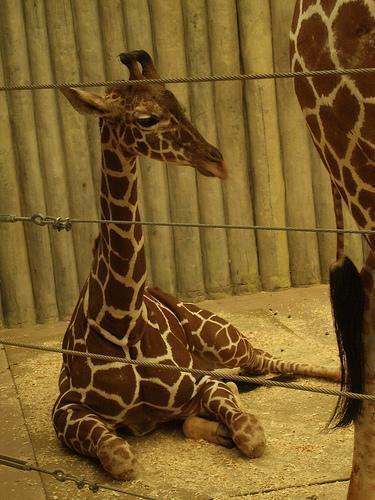How many ears are visible?
Give a very brief answer. 1. How many animals in the picture?
Give a very brief answer. 2. How many legs are shown?
Give a very brief answer. 4. 